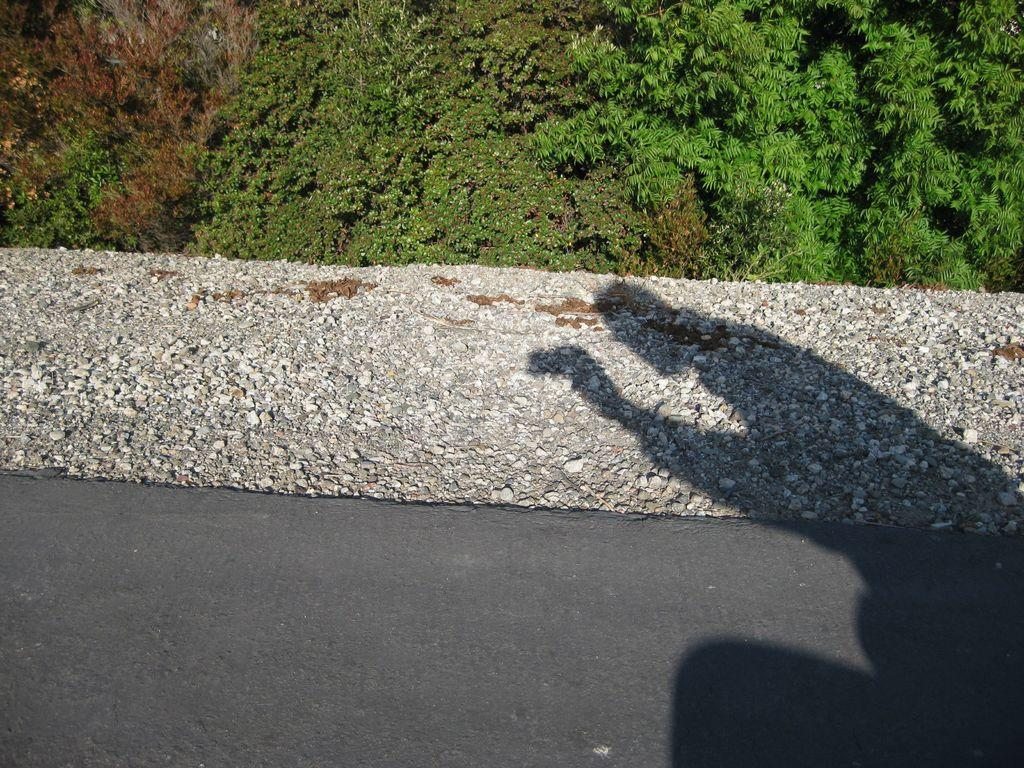What can be seen on the ground in the image? There is a shadow of a person on the ground, and there are stones on the ground. What is visible in the background of the image? There are trees in the background of the image. Can you tell me how many hospitals are visible in the image? There are no hospitals present in the image. What type of ocean can be seen in the background of the image? There is no ocean present in the image; it features trees in the background. 